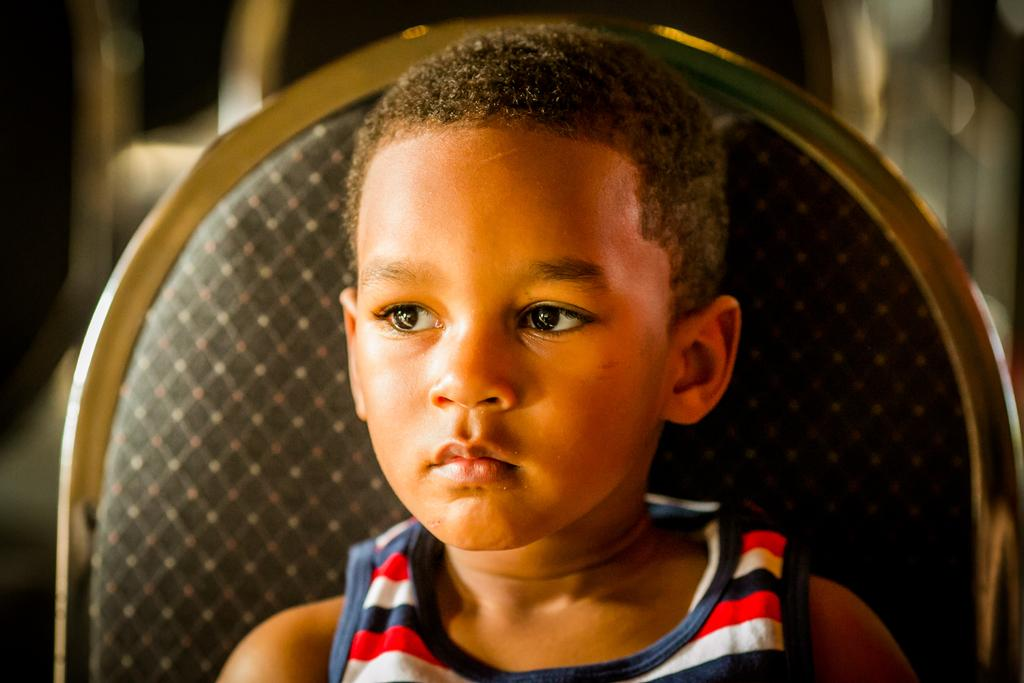What is the main subject in the foreground of the image? There is a kid in the foreground of the image. What is the kid doing in the image? The kid is sitting on a chair. Can you describe the background of the image? The background of the image is blurred. Can you see a snake slithering on the chair next to the kid in the image? There is no snake present in the image; the focus is on the kid sitting on the chair. 